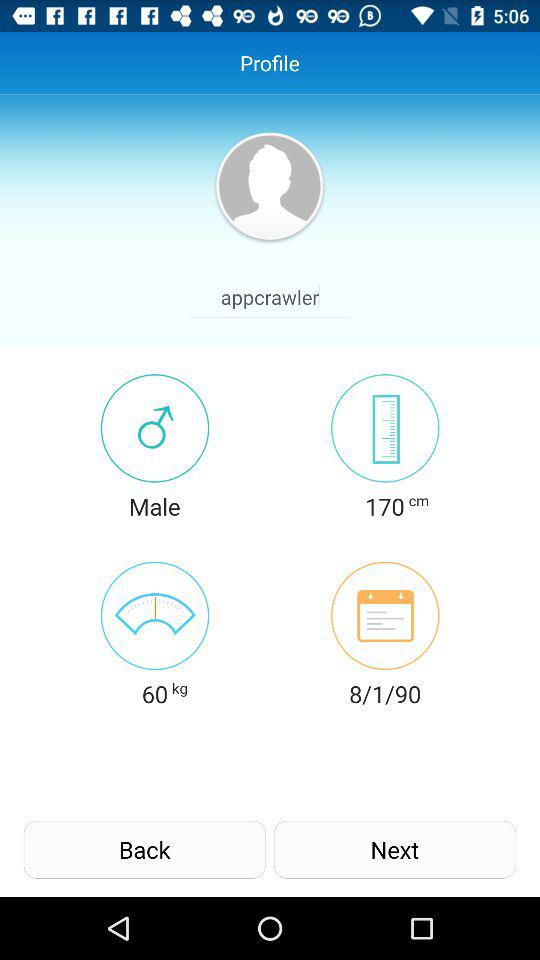What is the height? The height is 170 cm. 